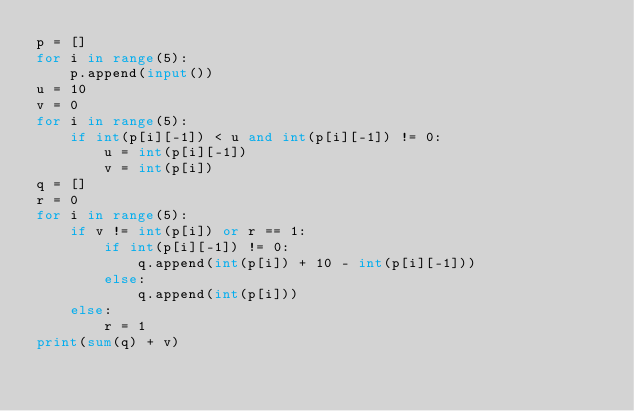Convert code to text. <code><loc_0><loc_0><loc_500><loc_500><_Python_>p = []
for i in range(5):
    p.append(input())
u = 10
v = 0
for i in range(5):
    if int(p[i][-1]) < u and int(p[i][-1]) != 0:
        u = int(p[i][-1])
        v = int(p[i])
q = []
r = 0
for i in range(5):
    if v != int(p[i]) or r == 1:
        if int(p[i][-1]) != 0:
            q.append(int(p[i]) + 10 - int(p[i][-1]))
        else:
            q.append(int(p[i]))
    else:
        r = 1
print(sum(q) + v)</code> 